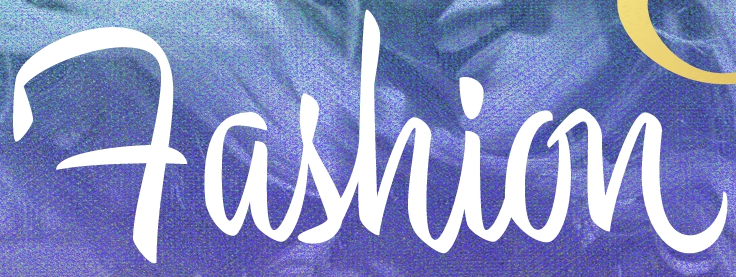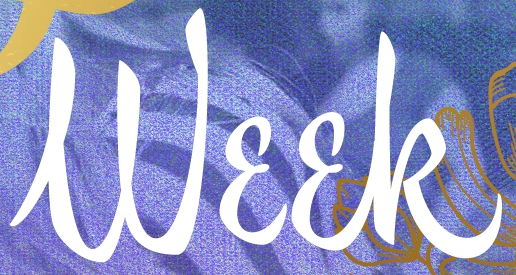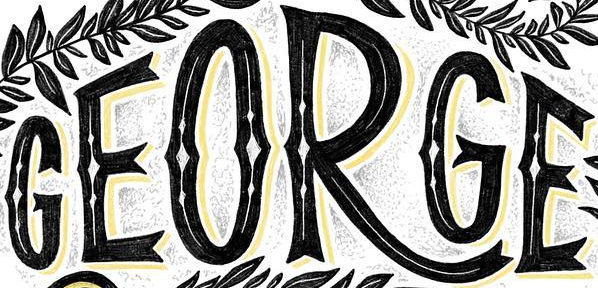Identify the words shown in these images in order, separated by a semicolon. Fashion; Week; GEORGE 